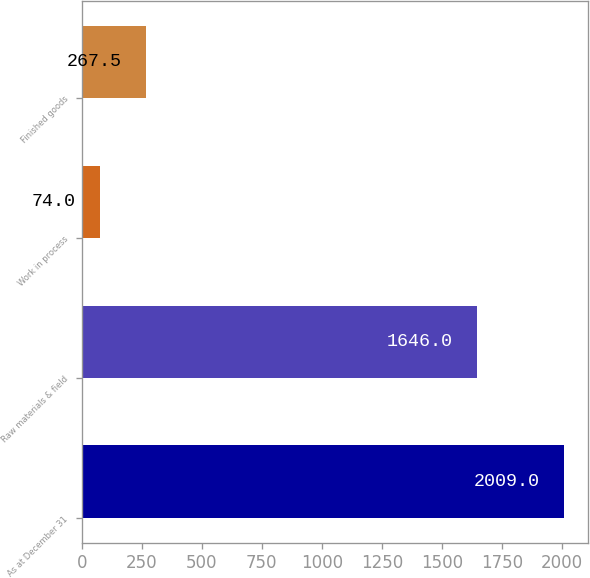Convert chart. <chart><loc_0><loc_0><loc_500><loc_500><bar_chart><fcel>As at December 31<fcel>Raw materials & field<fcel>Work in process<fcel>Finished goods<nl><fcel>2009<fcel>1646<fcel>74<fcel>267.5<nl></chart> 